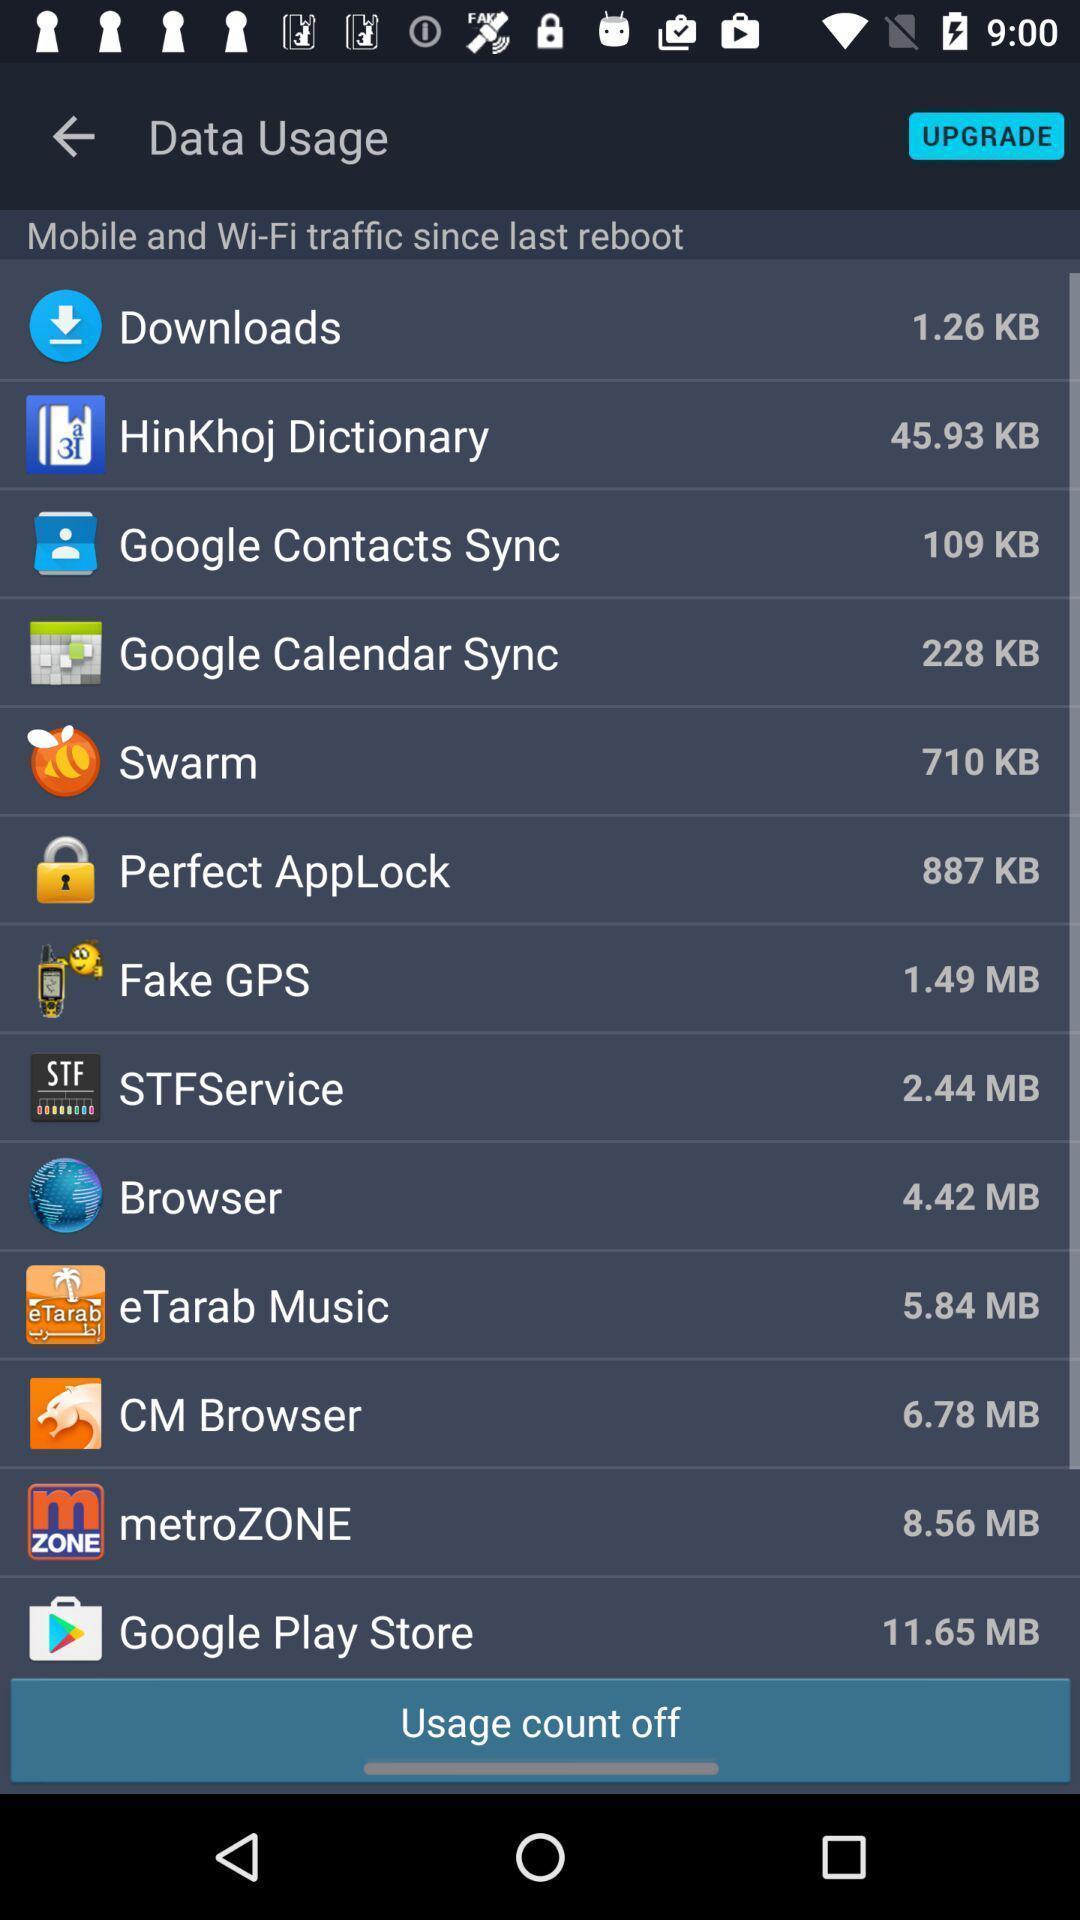Explain the elements present in this screenshot. Page showing different applications. 